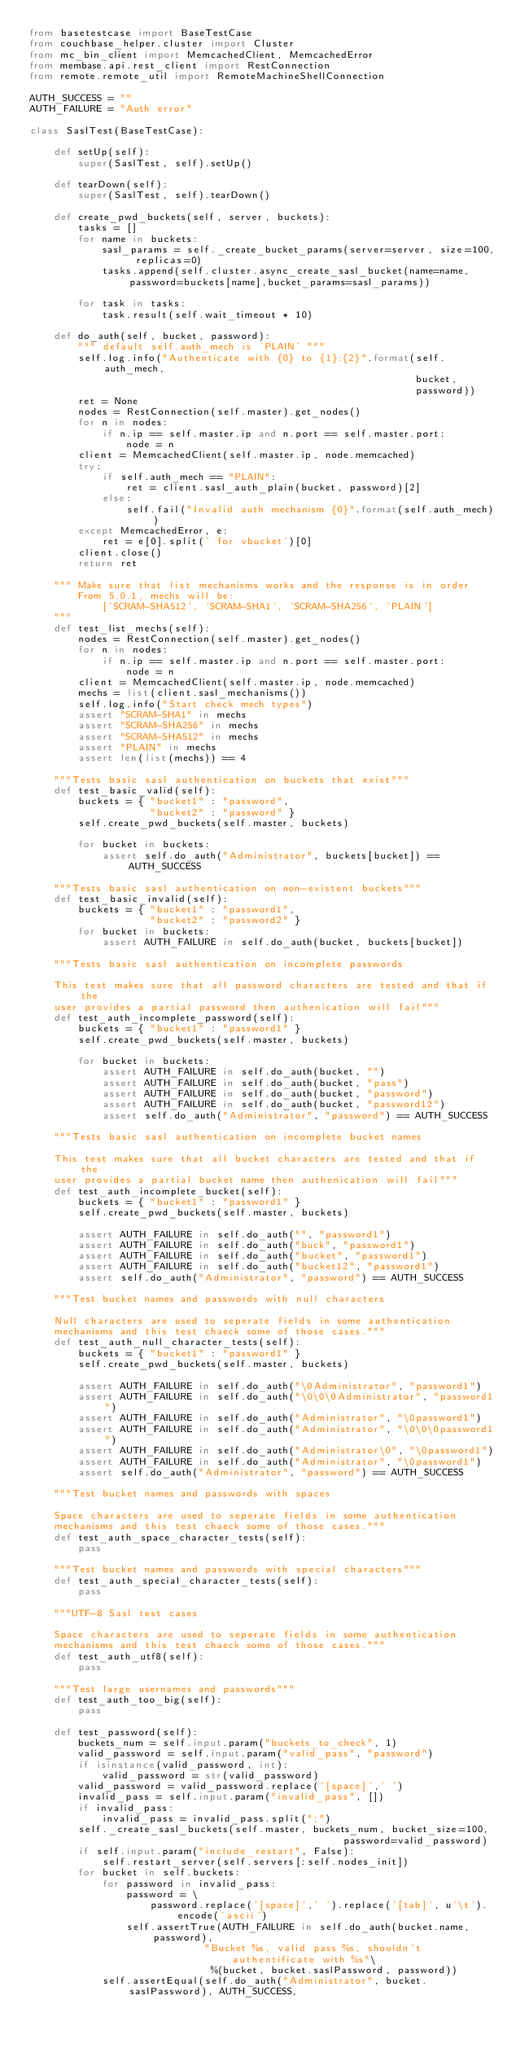Convert code to text. <code><loc_0><loc_0><loc_500><loc_500><_Python_>from basetestcase import BaseTestCase
from couchbase_helper.cluster import Cluster
from mc_bin_client import MemcachedClient, MemcachedError
from membase.api.rest_client import RestConnection
from remote.remote_util import RemoteMachineShellConnection

AUTH_SUCCESS = ""
AUTH_FAILURE = "Auth error"

class SaslTest(BaseTestCase):

    def setUp(self):
        super(SaslTest, self).setUp()

    def tearDown(self):
        super(SaslTest, self).tearDown()

    def create_pwd_buckets(self, server, buckets):
        tasks = []
        for name in buckets:
            sasl_params = self._create_bucket_params(server=server, size=100, replicas=0)
            tasks.append(self.cluster.async_create_sasl_bucket(name=name, password=buckets[name],bucket_params=sasl_params))

        for task in tasks:
            task.result(self.wait_timeout * 10)

    def do_auth(self, bucket, password):
        """ default self.auth_mech is 'PLAIN' """
        self.log.info("Authenticate with {0} to {1}:{2}".format(self.auth_mech,
                                                                bucket,
                                                                password))
        ret = None
        nodes = RestConnection(self.master).get_nodes()
        for n in nodes:
            if n.ip == self.master.ip and n.port == self.master.port:
                node = n
        client = MemcachedClient(self.master.ip, node.memcached)
        try:
            if self.auth_mech == "PLAIN":
                ret = client.sasl_auth_plain(bucket, password)[2]
            else:
                self.fail("Invalid auth mechanism {0}".format(self.auth_mech))
        except MemcachedError, e:
            ret = e[0].split(' for vbucket')[0]
        client.close()
        return ret

    """ Make sure that list mechanisms works and the response is in order
        From 5.0.1, mechs will be:
            ['SCRAM-SHA512', 'SCRAM-SHA1', 'SCRAM-SHA256', 'PLAIN']
    """
    def test_list_mechs(self):
        nodes = RestConnection(self.master).get_nodes()
        for n in nodes:
            if n.ip == self.master.ip and n.port == self.master.port:
                node = n
        client = MemcachedClient(self.master.ip, node.memcached)
        mechs = list(client.sasl_mechanisms())
        self.log.info("Start check mech types")
        assert "SCRAM-SHA1" in mechs
        assert "SCRAM-SHA256" in mechs
        assert "SCRAM-SHA512" in mechs
        assert "PLAIN" in mechs
        assert len(list(mechs)) == 4

    """Tests basic sasl authentication on buckets that exist"""
    def test_basic_valid(self):
        buckets = { "bucket1" : "password",
                    "bucket2" : "password" }
        self.create_pwd_buckets(self.master, buckets)

        for bucket in buckets:
            assert self.do_auth("Administrator", buckets[bucket]) == AUTH_SUCCESS

    """Tests basic sasl authentication on non-existent buckets"""
    def test_basic_invalid(self):
        buckets = { "bucket1" : "password1",
                    "bucket2" : "password2" }
        for bucket in buckets:
            assert AUTH_FAILURE in self.do_auth(bucket, buckets[bucket])

    """Tests basic sasl authentication on incomplete passwords

    This test makes sure that all password characters are tested and that if the
    user provides a partial password then authenication will fail"""
    def test_auth_incomplete_password(self):
        buckets = { "bucket1" : "password1" }
        self.create_pwd_buckets(self.master, buckets)

        for bucket in buckets:
            assert AUTH_FAILURE in self.do_auth(bucket, "")
            assert AUTH_FAILURE in self.do_auth(bucket, "pass")
            assert AUTH_FAILURE in self.do_auth(bucket, "password")
            assert AUTH_FAILURE in self.do_auth(bucket, "password12")
            assert self.do_auth("Administrator", "password") == AUTH_SUCCESS

    """Tests basic sasl authentication on incomplete bucket names

    This test makes sure that all bucket characters are tested and that if the
    user provides a partial bucket name then authenication will fail"""
    def test_auth_incomplete_bucket(self):
        buckets = { "bucket1" : "password1" }
        self.create_pwd_buckets(self.master, buckets)

        assert AUTH_FAILURE in self.do_auth("", "password1")
        assert AUTH_FAILURE in self.do_auth("buck", "password1")
        assert AUTH_FAILURE in self.do_auth("bucket", "password1")
        assert AUTH_FAILURE in self.do_auth("bucket12", "password1")
        assert self.do_auth("Administrator", "password") == AUTH_SUCCESS

    """Test bucket names and passwords with null characters

    Null characters are used to seperate fields in some authentication
    mechanisms and this test chaeck some of those cases."""
    def test_auth_null_character_tests(self):
        buckets = { "bucket1" : "password1" }
        self.create_pwd_buckets(self.master, buckets)

        assert AUTH_FAILURE in self.do_auth("\0Administrator", "password1")
        assert AUTH_FAILURE in self.do_auth("\0\0\0Administrator", "password1")
        assert AUTH_FAILURE in self.do_auth("Administrator", "\0password1")
        assert AUTH_FAILURE in self.do_auth("Administrator", "\0\0\0password1")
        assert AUTH_FAILURE in self.do_auth("Administrator\0", "\0password1")
        assert AUTH_FAILURE in self.do_auth("Administrator", "\0password1")
        assert self.do_auth("Administrator", "password") == AUTH_SUCCESS

    """Test bucket names and passwords with spaces

    Space characters are used to seperate fields in some authentication
    mechanisms and this test chaeck some of those cases."""
    def test_auth_space_character_tests(self):
        pass

    """Test bucket names and passwords with special characters"""
    def test_auth_special_character_tests(self):
        pass

    """UTF-8 Sasl test cases

    Space characters are used to seperate fields in some authentication
    mechanisms and this test chaeck some of those cases."""
    def test_auth_utf8(self):
        pass

    """Test large usernames and passwords"""
    def test_auth_too_big(self):
        pass

    def test_password(self):
        buckets_num = self.input.param("buckets_to_check", 1)
        valid_password = self.input.param("valid_pass", "password")
        if isinstance(valid_password, int):
            valid_password = str(valid_password)
        valid_password = valid_password.replace('[space]',' ')
        invalid_pass = self.input.param("invalid_pass", [])
        if invalid_pass:
            invalid_pass = invalid_pass.split(";")
        self._create_sasl_buckets(self.master, buckets_num, bucket_size=100,
                                                    password=valid_password)
        if self.input.param("include_restart", False):
            self.restart_server(self.servers[:self.nodes_init])
        for bucket in self.buckets:
            for password in invalid_pass:
                password = \
                    password.replace('[space]',' ').replace('[tab]', u'\t').encode('ascii')
                self.assertTrue(AUTH_FAILURE in self.do_auth(bucket.name, password),
                             "Bucket %s, valid pass %s, shouldn't authentificate with %s"\
                              %(bucket, bucket.saslPassword, password))
            self.assertEqual(self.do_auth("Administrator", bucket.saslPassword), AUTH_SUCCESS,</code> 